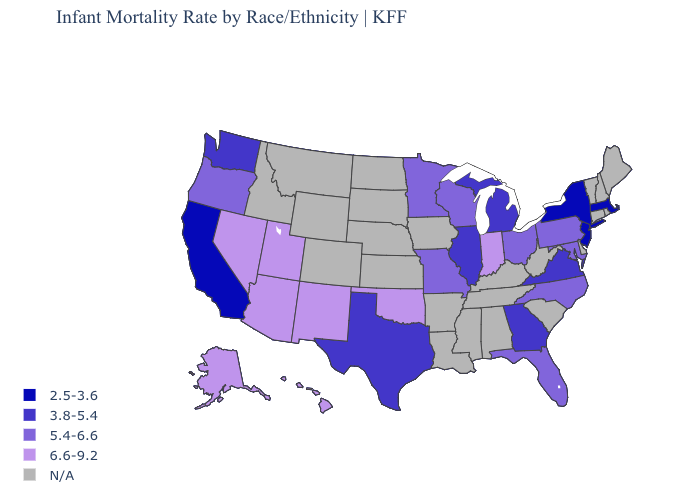What is the value of Illinois?
Quick response, please. 3.8-5.4. Name the states that have a value in the range 3.8-5.4?
Quick response, please. Georgia, Illinois, Michigan, Texas, Virginia, Washington. What is the highest value in the West ?
Write a very short answer. 6.6-9.2. What is the value of New York?
Give a very brief answer. 2.5-3.6. What is the value of Vermont?
Concise answer only. N/A. Name the states that have a value in the range 3.8-5.4?
Quick response, please. Georgia, Illinois, Michigan, Texas, Virginia, Washington. Among the states that border New Jersey , which have the lowest value?
Quick response, please. New York. Among the states that border Wisconsin , does Michigan have the lowest value?
Write a very short answer. Yes. Among the states that border Michigan , which have the lowest value?
Answer briefly. Ohio, Wisconsin. Name the states that have a value in the range 3.8-5.4?
Answer briefly. Georgia, Illinois, Michigan, Texas, Virginia, Washington. Does the map have missing data?
Answer briefly. Yes. Name the states that have a value in the range 6.6-9.2?
Concise answer only. Alaska, Arizona, Hawaii, Indiana, Nevada, New Mexico, Oklahoma, Utah. What is the value of Hawaii?
Be succinct. 6.6-9.2. Among the states that border Pennsylvania , which have the lowest value?
Give a very brief answer. New Jersey, New York. 